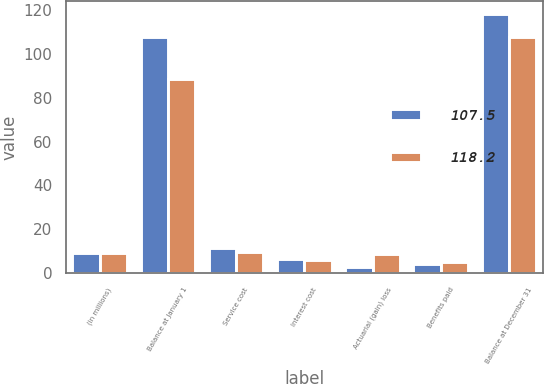Convert chart. <chart><loc_0><loc_0><loc_500><loc_500><stacked_bar_chart><ecel><fcel>(in millions)<fcel>Balance at January 1<fcel>Service cost<fcel>Interest cost<fcel>Actuarial (gain) loss<fcel>Benefits paid<fcel>Balance at December 31<nl><fcel>107.5<fcel>9.25<fcel>107.5<fcel>11.6<fcel>6.5<fcel>3<fcel>4.4<fcel>118.2<nl><fcel>118.2<fcel>9.25<fcel>88.4<fcel>9.7<fcel>5.9<fcel>8.8<fcel>5.3<fcel>107.5<nl></chart> 